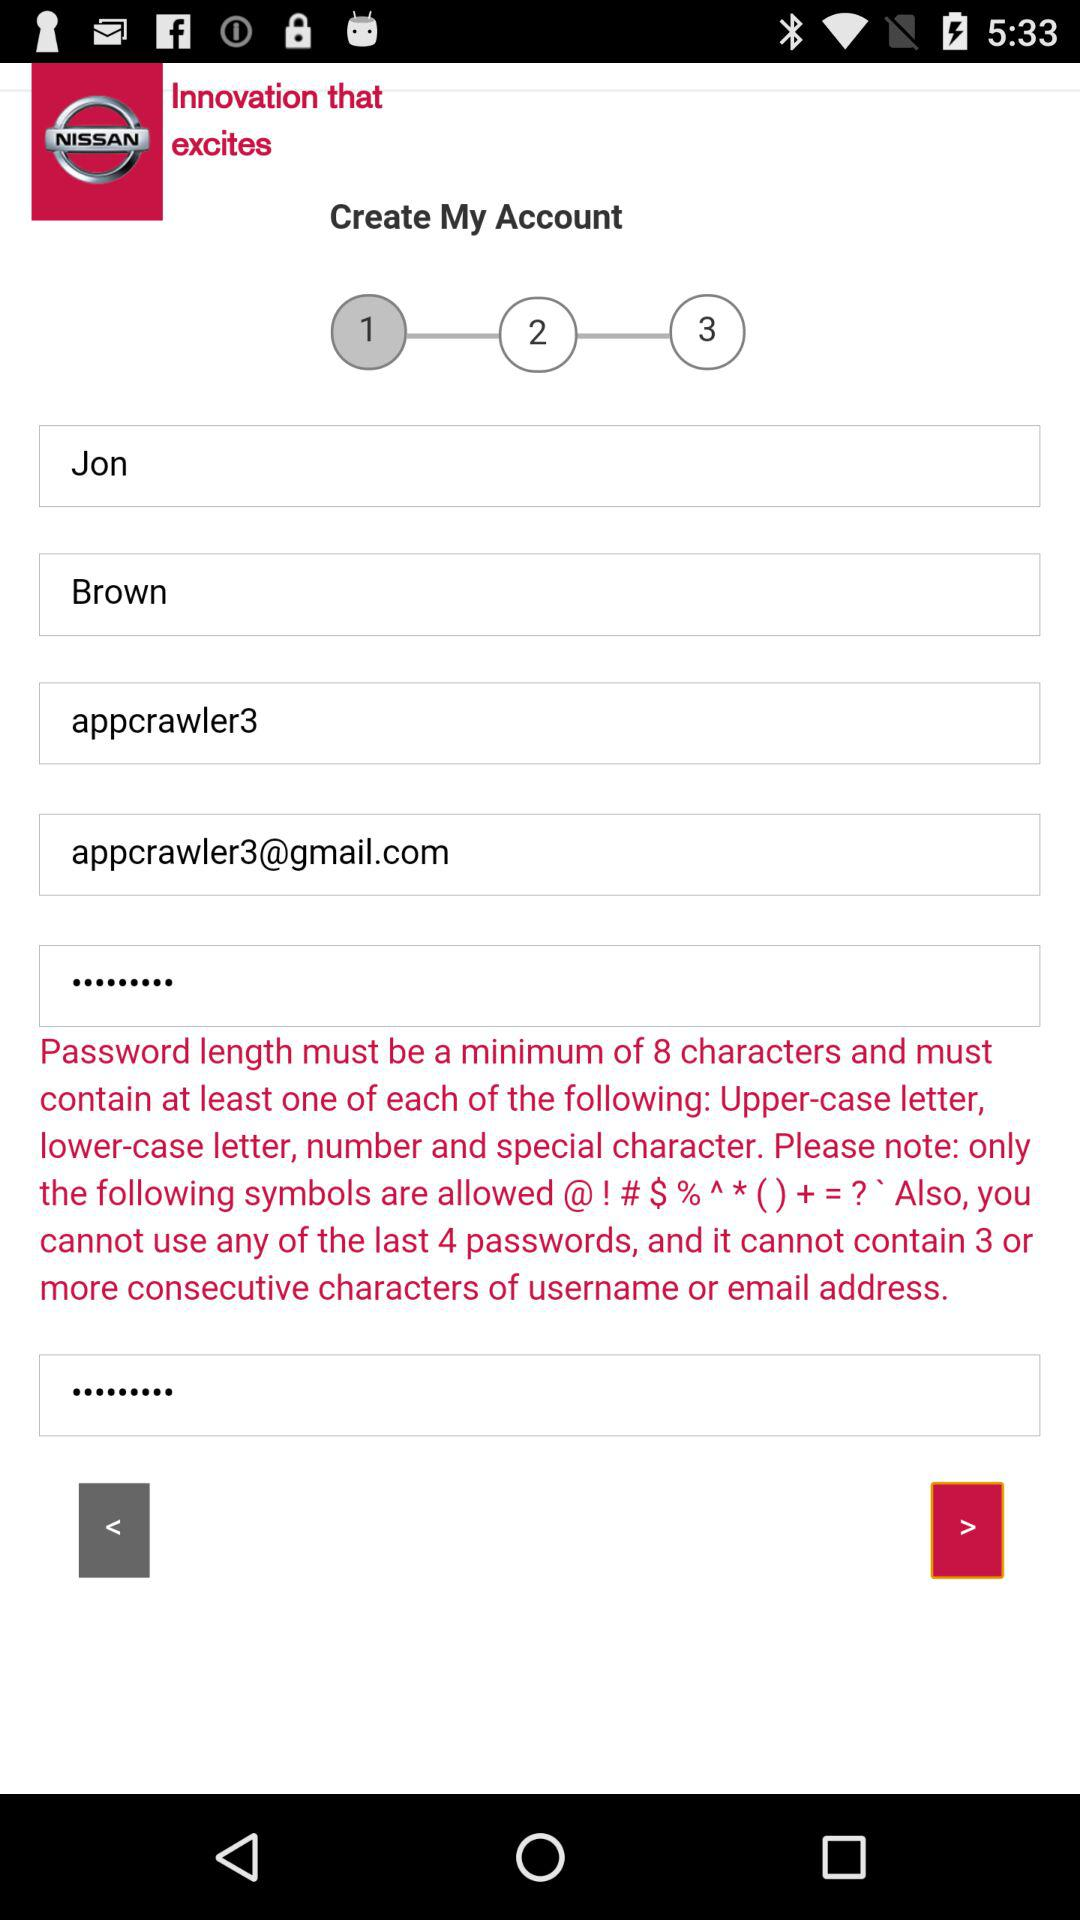Which things are required to create a password? Password length must be a minimum of 8 characters and must contain at least one of each of the following: an upper-case letter, a lower-case letter, a number and a special character. Please note: only the following symbols are allowed @! # $ % ^ * ( ) + =? ` Also, you cannot use any of the last 4 passwords and it cannot contain 3 or more consecutive characters of the username or email address. 